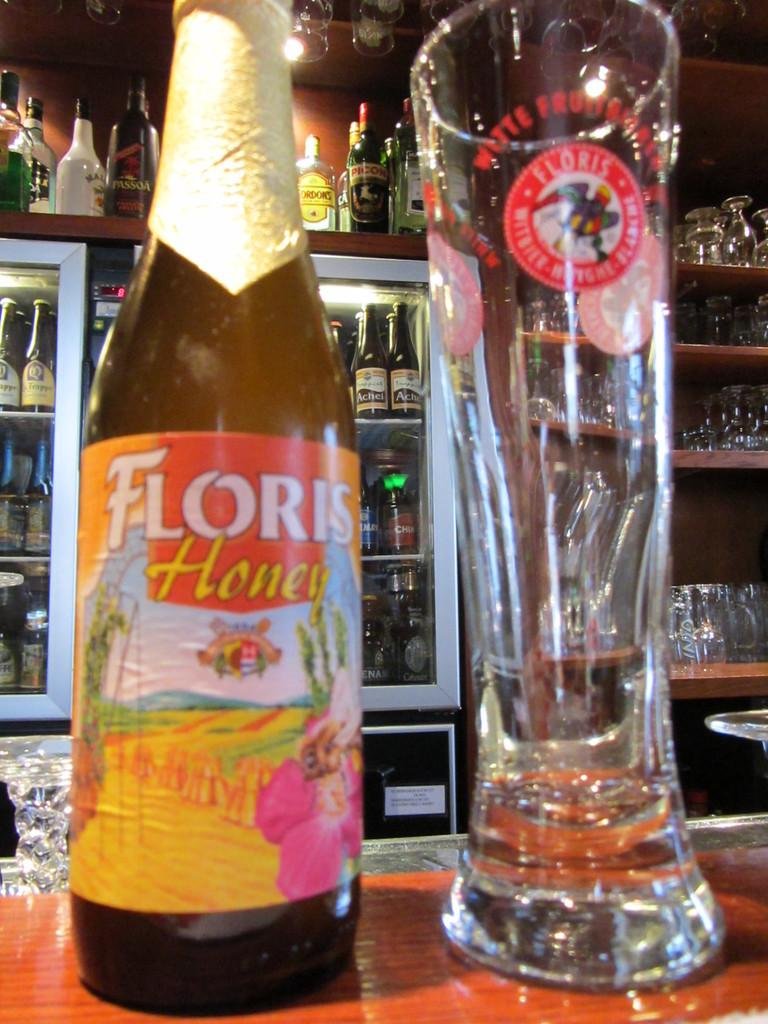What is on the table in the image? There is a bottle of champagne and a glass on the table in the image. What is the bottle of champagne used for? The bottle of champagne is likely used for drinking or celebrating. What else can be seen on the table besides the bottle of champagne and the glass? There are no other items visible on the table in the image. What type of glasses are present in the image? There are glasses present in the image, but the specific type is not mentioned in the facts. What is the purpose of the racks full of alcohol in the image? The racks full of alcohol are likely used for storage or display. How does the wren contribute to the distribution of alcohol in the image? There is no wren present in the image, and therefore it cannot contribute to the distribution of alcohol. 